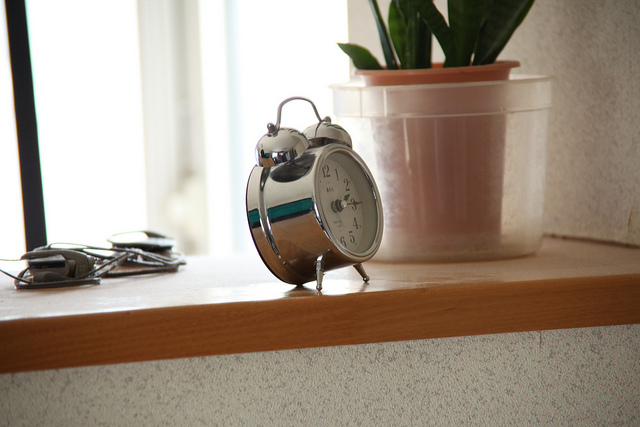Identify the text displayed in this image. 12 1 2 3 4 5 6 